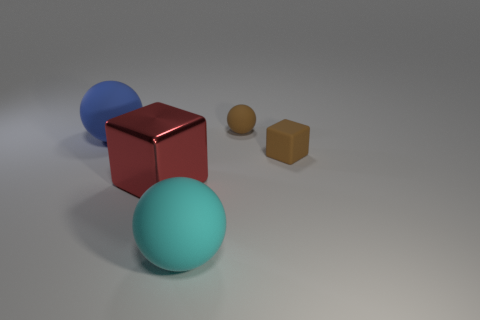Add 3 brown matte spheres. How many objects exist? 8 Subtract all blocks. How many objects are left? 3 Subtract all blue blocks. Subtract all balls. How many objects are left? 2 Add 4 brown matte spheres. How many brown matte spheres are left? 5 Add 4 large metal objects. How many large metal objects exist? 5 Subtract 0 yellow spheres. How many objects are left? 5 